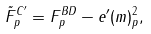<formula> <loc_0><loc_0><loc_500><loc_500>\tilde { F } ^ { C ^ { \prime } } _ { p } = F ^ { B D } _ { p } - e ^ { \prime } ( m ) _ { p } ^ { 2 } ,</formula> 